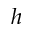<formula> <loc_0><loc_0><loc_500><loc_500>h</formula> 